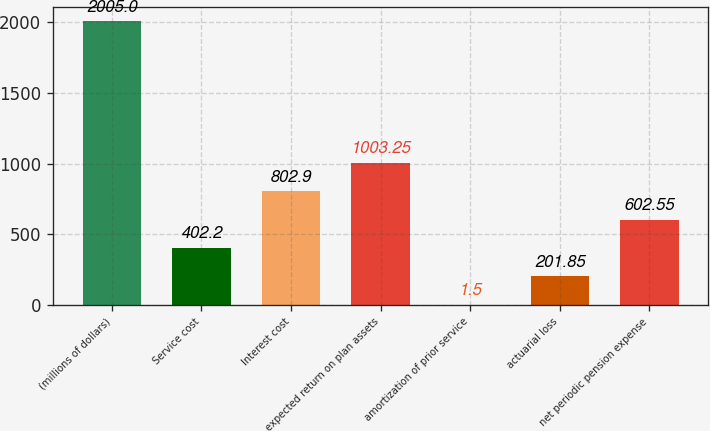Convert chart. <chart><loc_0><loc_0><loc_500><loc_500><bar_chart><fcel>(millions of dollars)<fcel>Service cost<fcel>Interest cost<fcel>expected return on plan assets<fcel>amortization of prior service<fcel>actuarial loss<fcel>net periodic pension expense<nl><fcel>2005<fcel>402.2<fcel>802.9<fcel>1003.25<fcel>1.5<fcel>201.85<fcel>602.55<nl></chart> 